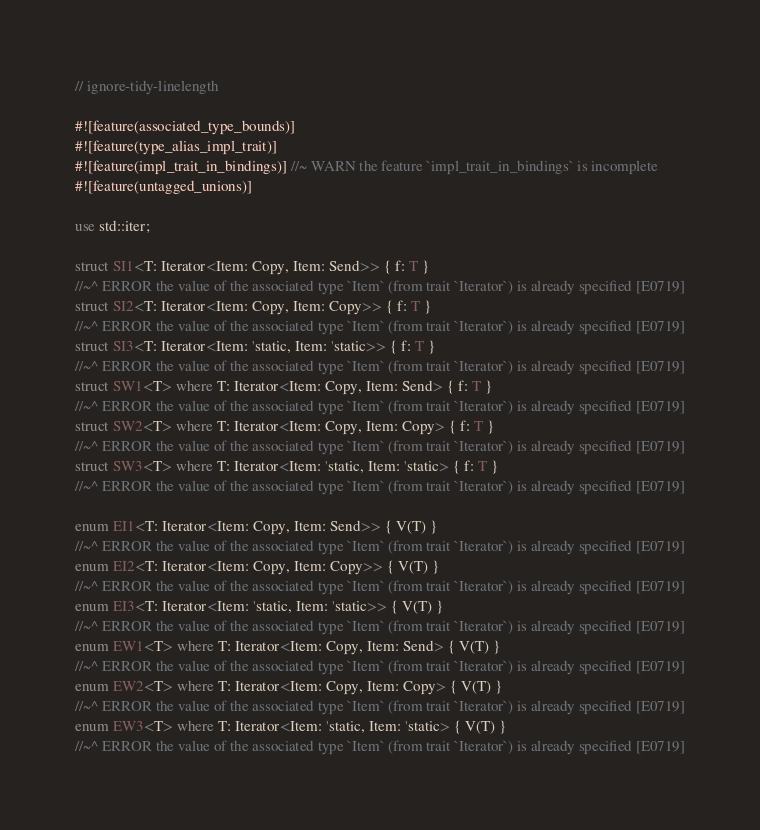Convert code to text. <code><loc_0><loc_0><loc_500><loc_500><_Rust_>// ignore-tidy-linelength

#![feature(associated_type_bounds)]
#![feature(type_alias_impl_trait)]
#![feature(impl_trait_in_bindings)] //~ WARN the feature `impl_trait_in_bindings` is incomplete
#![feature(untagged_unions)]

use std::iter;

struct SI1<T: Iterator<Item: Copy, Item: Send>> { f: T }
//~^ ERROR the value of the associated type `Item` (from trait `Iterator`) is already specified [E0719]
struct SI2<T: Iterator<Item: Copy, Item: Copy>> { f: T }
//~^ ERROR the value of the associated type `Item` (from trait `Iterator`) is already specified [E0719]
struct SI3<T: Iterator<Item: 'static, Item: 'static>> { f: T }
//~^ ERROR the value of the associated type `Item` (from trait `Iterator`) is already specified [E0719]
struct SW1<T> where T: Iterator<Item: Copy, Item: Send> { f: T }
//~^ ERROR the value of the associated type `Item` (from trait `Iterator`) is already specified [E0719]
struct SW2<T> where T: Iterator<Item: Copy, Item: Copy> { f: T }
//~^ ERROR the value of the associated type `Item` (from trait `Iterator`) is already specified [E0719]
struct SW3<T> where T: Iterator<Item: 'static, Item: 'static> { f: T }
//~^ ERROR the value of the associated type `Item` (from trait `Iterator`) is already specified [E0719]

enum EI1<T: Iterator<Item: Copy, Item: Send>> { V(T) }
//~^ ERROR the value of the associated type `Item` (from trait `Iterator`) is already specified [E0719]
enum EI2<T: Iterator<Item: Copy, Item: Copy>> { V(T) }
//~^ ERROR the value of the associated type `Item` (from trait `Iterator`) is already specified [E0719]
enum EI3<T: Iterator<Item: 'static, Item: 'static>> { V(T) }
//~^ ERROR the value of the associated type `Item` (from trait `Iterator`) is already specified [E0719]
enum EW1<T> where T: Iterator<Item: Copy, Item: Send> { V(T) }
//~^ ERROR the value of the associated type `Item` (from trait `Iterator`) is already specified [E0719]
enum EW2<T> where T: Iterator<Item: Copy, Item: Copy> { V(T) }
//~^ ERROR the value of the associated type `Item` (from trait `Iterator`) is already specified [E0719]
enum EW3<T> where T: Iterator<Item: 'static, Item: 'static> { V(T) }
//~^ ERROR the value of the associated type `Item` (from trait `Iterator`) is already specified [E0719]
</code> 